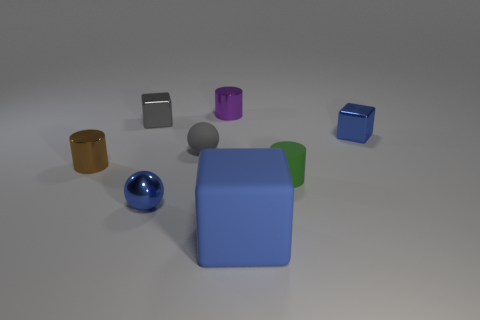Subtract all brown cylinders. How many blue blocks are left? 2 Subtract 1 cylinders. How many cylinders are left? 2 Add 2 small blue metal things. How many objects exist? 10 Subtract all blocks. How many objects are left? 5 Add 8 large blocks. How many large blocks are left? 9 Add 3 blue metallic things. How many blue metallic things exist? 5 Subtract 0 brown blocks. How many objects are left? 8 Subtract all big brown matte objects. Subtract all metal objects. How many objects are left? 3 